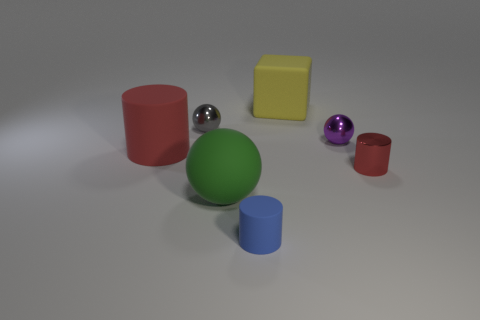There is a big thing that is the same color as the metallic cylinder; what is it made of?
Your answer should be compact. Rubber. What number of matte things are large cubes or large red spheres?
Offer a terse response. 1. Are the large yellow thing and the large red object made of the same material?
Keep it short and to the point. Yes. What material is the ball that is in front of the large cylinder that is to the left of the blue rubber thing made of?
Provide a short and direct response. Rubber. What number of large objects are either brown rubber objects or green matte things?
Offer a terse response. 1. The blue object is what size?
Offer a terse response. Small. Is the number of small metal balls that are in front of the tiny red metallic thing greater than the number of blue rubber objects?
Provide a short and direct response. No. Is the number of matte objects that are in front of the tiny gray ball the same as the number of tiny blue rubber cylinders that are left of the big red cylinder?
Provide a succinct answer. No. There is a matte thing that is both on the right side of the green object and in front of the tiny red shiny cylinder; what color is it?
Offer a very short reply. Blue. Is there any other thing that has the same size as the blue thing?
Ensure brevity in your answer.  Yes. 